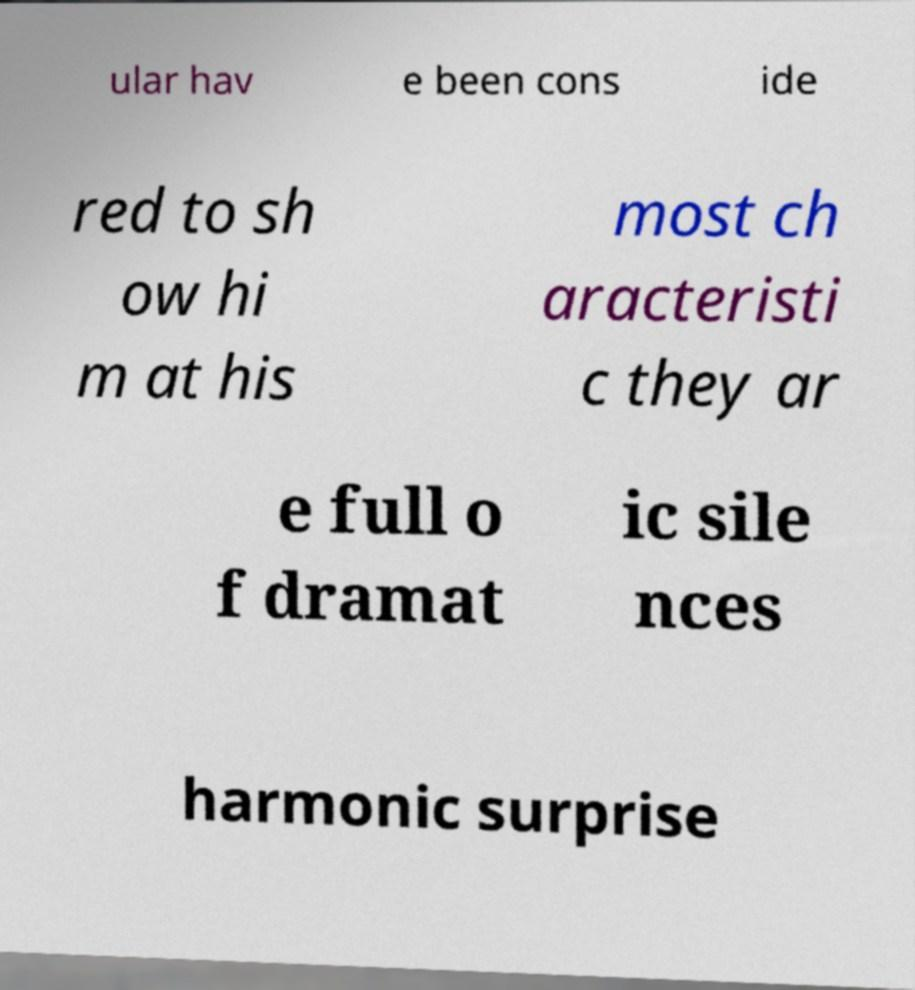There's text embedded in this image that I need extracted. Can you transcribe it verbatim? ular hav e been cons ide red to sh ow hi m at his most ch aracteristi c they ar e full o f dramat ic sile nces harmonic surprise 